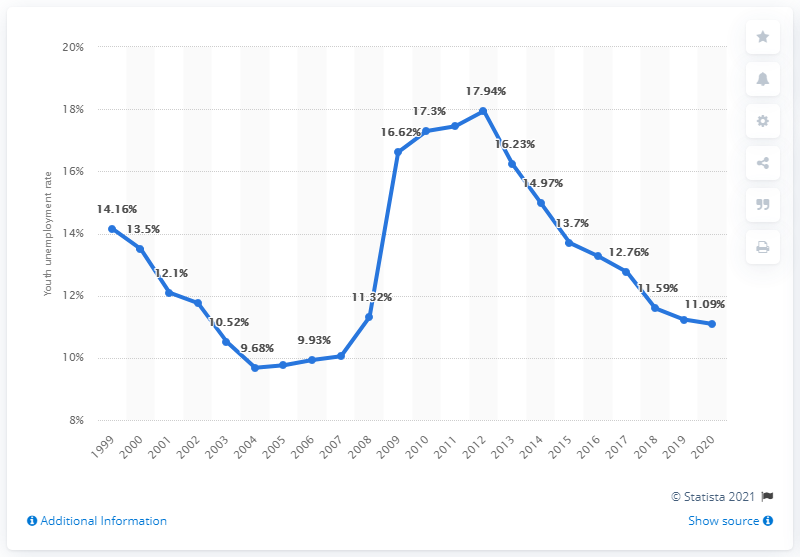Point out several critical features in this image. In 2020, the youth unemployment rate in New Zealand was 11.09%. 